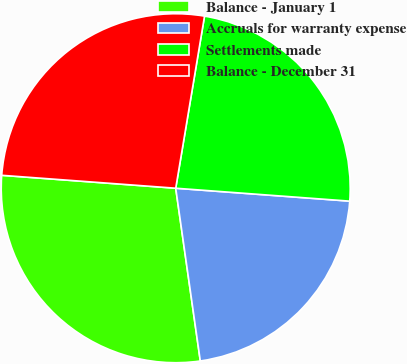Convert chart. <chart><loc_0><loc_0><loc_500><loc_500><pie_chart><fcel>Balance - January 1<fcel>Accruals for warranty expense<fcel>Settlements made<fcel>Balance - December 31<nl><fcel>28.43%<fcel>21.57%<fcel>23.54%<fcel>26.46%<nl></chart> 